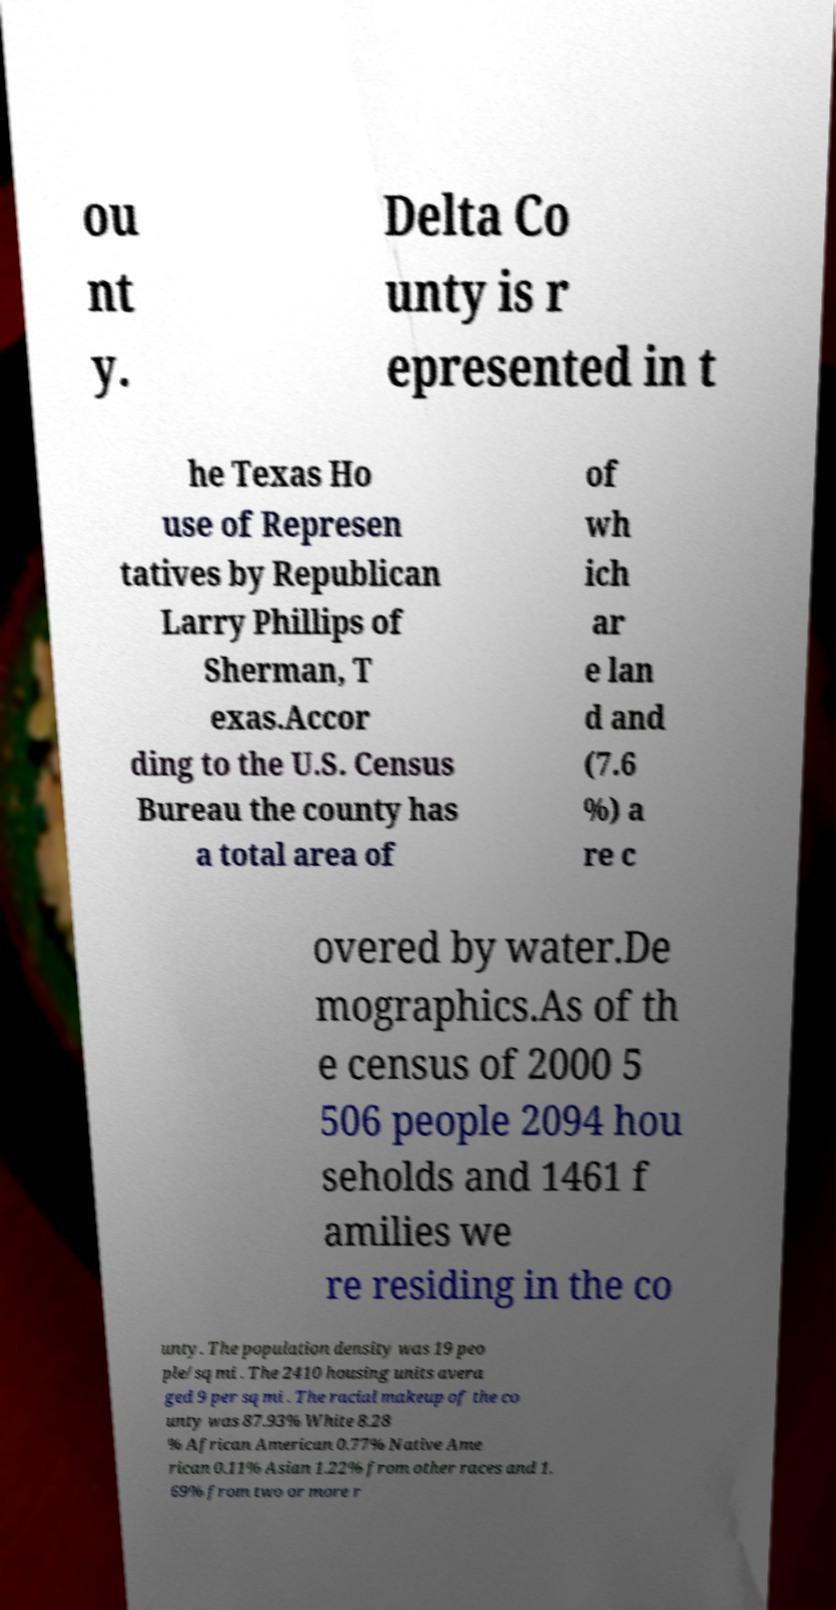Can you read and provide the text displayed in the image?This photo seems to have some interesting text. Can you extract and type it out for me? ou nt y. Delta Co unty is r epresented in t he Texas Ho use of Represen tatives by Republican Larry Phillips of Sherman, T exas.Accor ding to the U.S. Census Bureau the county has a total area of of wh ich ar e lan d and (7.6 %) a re c overed by water.De mographics.As of th e census of 2000 5 506 people 2094 hou seholds and 1461 f amilies we re residing in the co unty. The population density was 19 peo ple/sq mi . The 2410 housing units avera ged 9 per sq mi . The racial makeup of the co unty was 87.93% White 8.28 % African American 0.77% Native Ame rican 0.11% Asian 1.22% from other races and 1. 69% from two or more r 